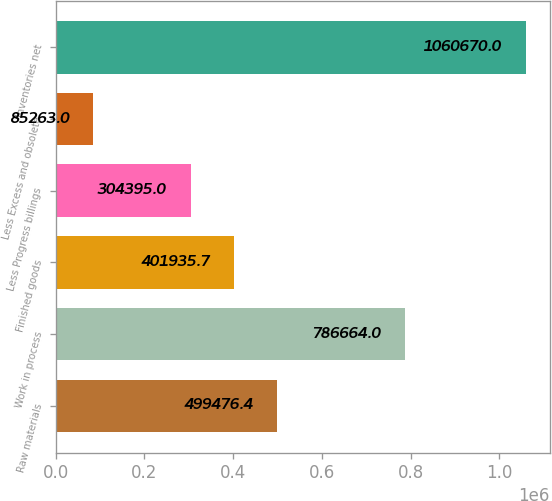<chart> <loc_0><loc_0><loc_500><loc_500><bar_chart><fcel>Raw materials<fcel>Work in process<fcel>Finished goods<fcel>Less Progress billings<fcel>Less Excess and obsolete<fcel>Inventories net<nl><fcel>499476<fcel>786664<fcel>401936<fcel>304395<fcel>85263<fcel>1.06067e+06<nl></chart> 